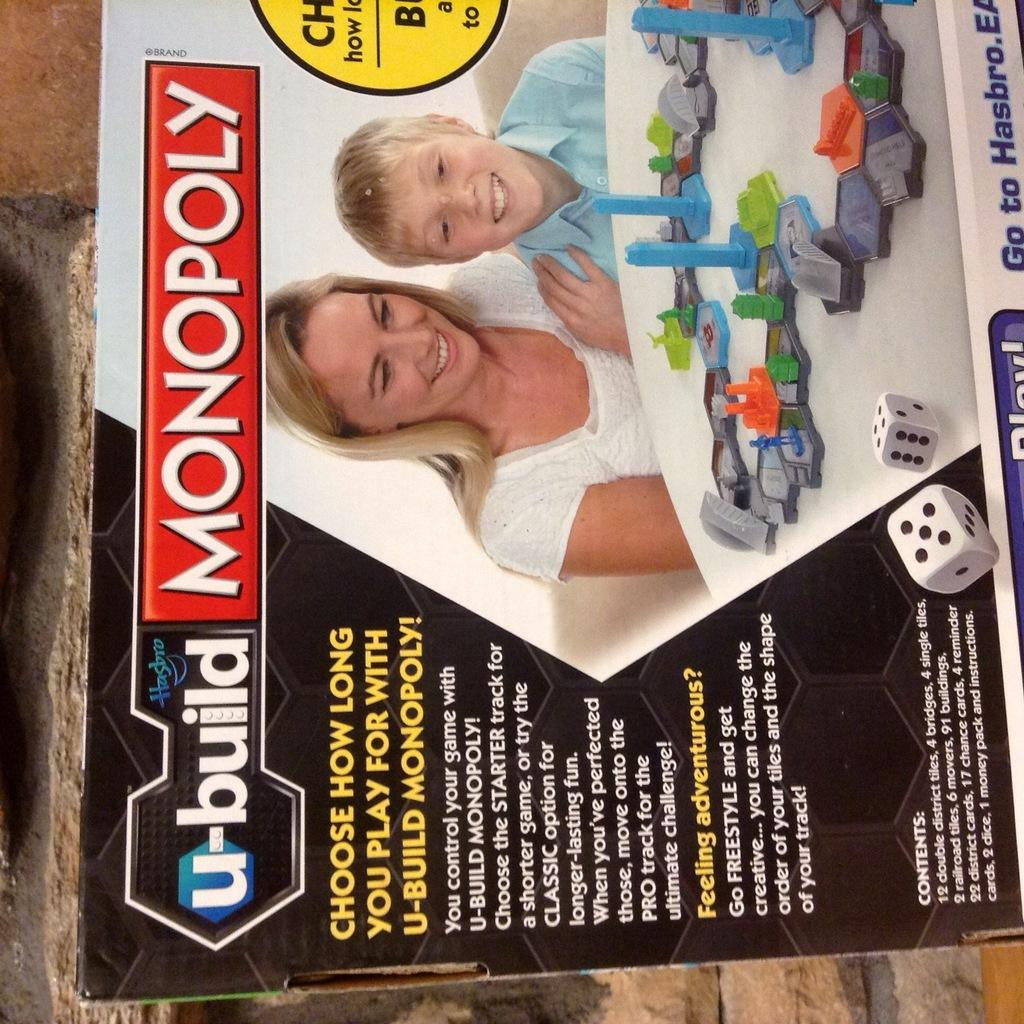What object is present in the image that might contain other items? There is a box in the image that might contain other items. What can be found on the surface of the box? There is text on the box. What type of game pieces are visible in the image? There are dice in the image. Who are the people present in the image? There is a woman and a boy in the image. What invention is being used by the woman in the image? There is no specific invention mentioned or depicted in the image; it only shows a box, dice, a woman, and a boy. 